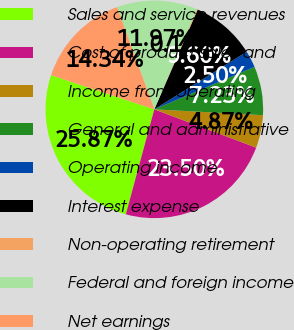<chart> <loc_0><loc_0><loc_500><loc_500><pie_chart><fcel>Sales and service revenues<fcel>Cost of product sales and<fcel>Income from operating<fcel>General and administrative<fcel>Operating income<fcel>Interest expense<fcel>Non-operating retirement<fcel>Federal and foreign income<fcel>Net earnings<nl><fcel>25.87%<fcel>23.5%<fcel>4.87%<fcel>7.23%<fcel>2.5%<fcel>9.6%<fcel>0.13%<fcel>11.97%<fcel>14.34%<nl></chart> 